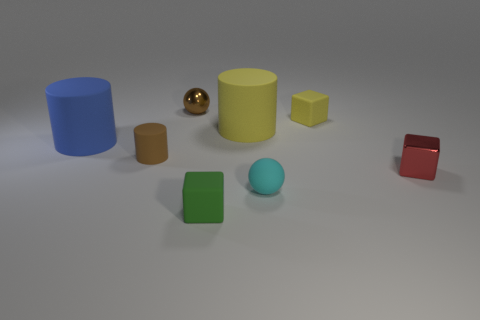What material is the large yellow object?
Give a very brief answer. Rubber. The green thing has what shape?
Your answer should be compact. Cube. What number of tiny cylinders are the same color as the tiny metallic ball?
Your answer should be very brief. 1. There is a sphere behind the tiny metal object in front of the big thing right of the brown matte thing; what is it made of?
Ensure brevity in your answer.  Metal. How many red things are either tiny spheres or tiny cubes?
Keep it short and to the point. 1. There is a yellow cylinder that is left of the small red metal object that is to the right of the big cylinder on the left side of the green thing; how big is it?
Your answer should be compact. Large. What size is the yellow matte object that is the same shape as the blue object?
Your answer should be compact. Large. What number of small objects are yellow matte cylinders or brown metallic cylinders?
Ensure brevity in your answer.  0. Are the object right of the small yellow matte object and the ball left of the cyan ball made of the same material?
Provide a succinct answer. Yes. What is the sphere that is in front of the tiny red cube made of?
Offer a very short reply. Rubber. 